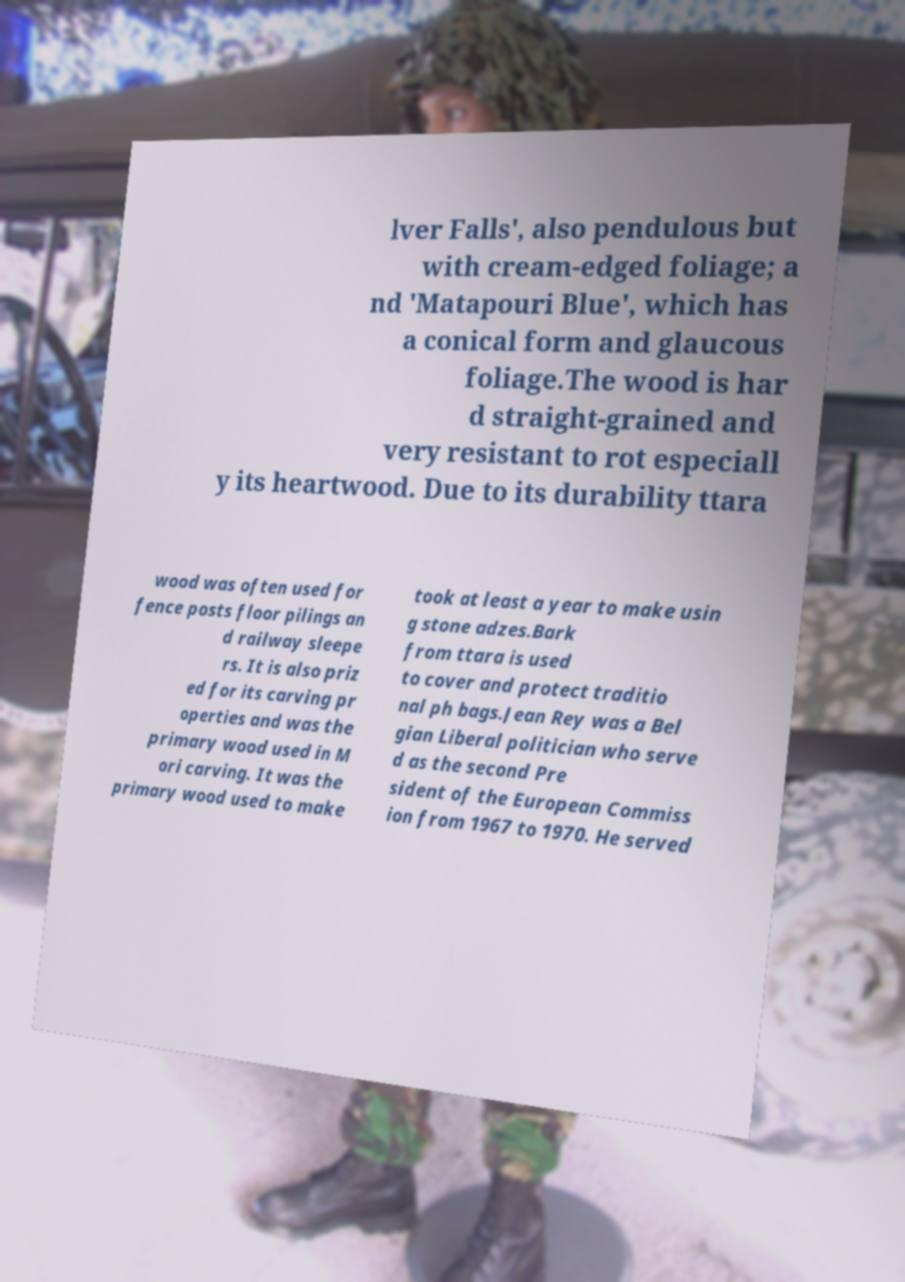Can you accurately transcribe the text from the provided image for me? lver Falls', also pendulous but with cream-edged foliage; a nd 'Matapouri Blue', which has a conical form and glaucous foliage.The wood is har d straight-grained and very resistant to rot especiall y its heartwood. Due to its durability ttara wood was often used for fence posts floor pilings an d railway sleepe rs. It is also priz ed for its carving pr operties and was the primary wood used in M ori carving. It was the primary wood used to make took at least a year to make usin g stone adzes.Bark from ttara is used to cover and protect traditio nal ph bags.Jean Rey was a Bel gian Liberal politician who serve d as the second Pre sident of the European Commiss ion from 1967 to 1970. He served 